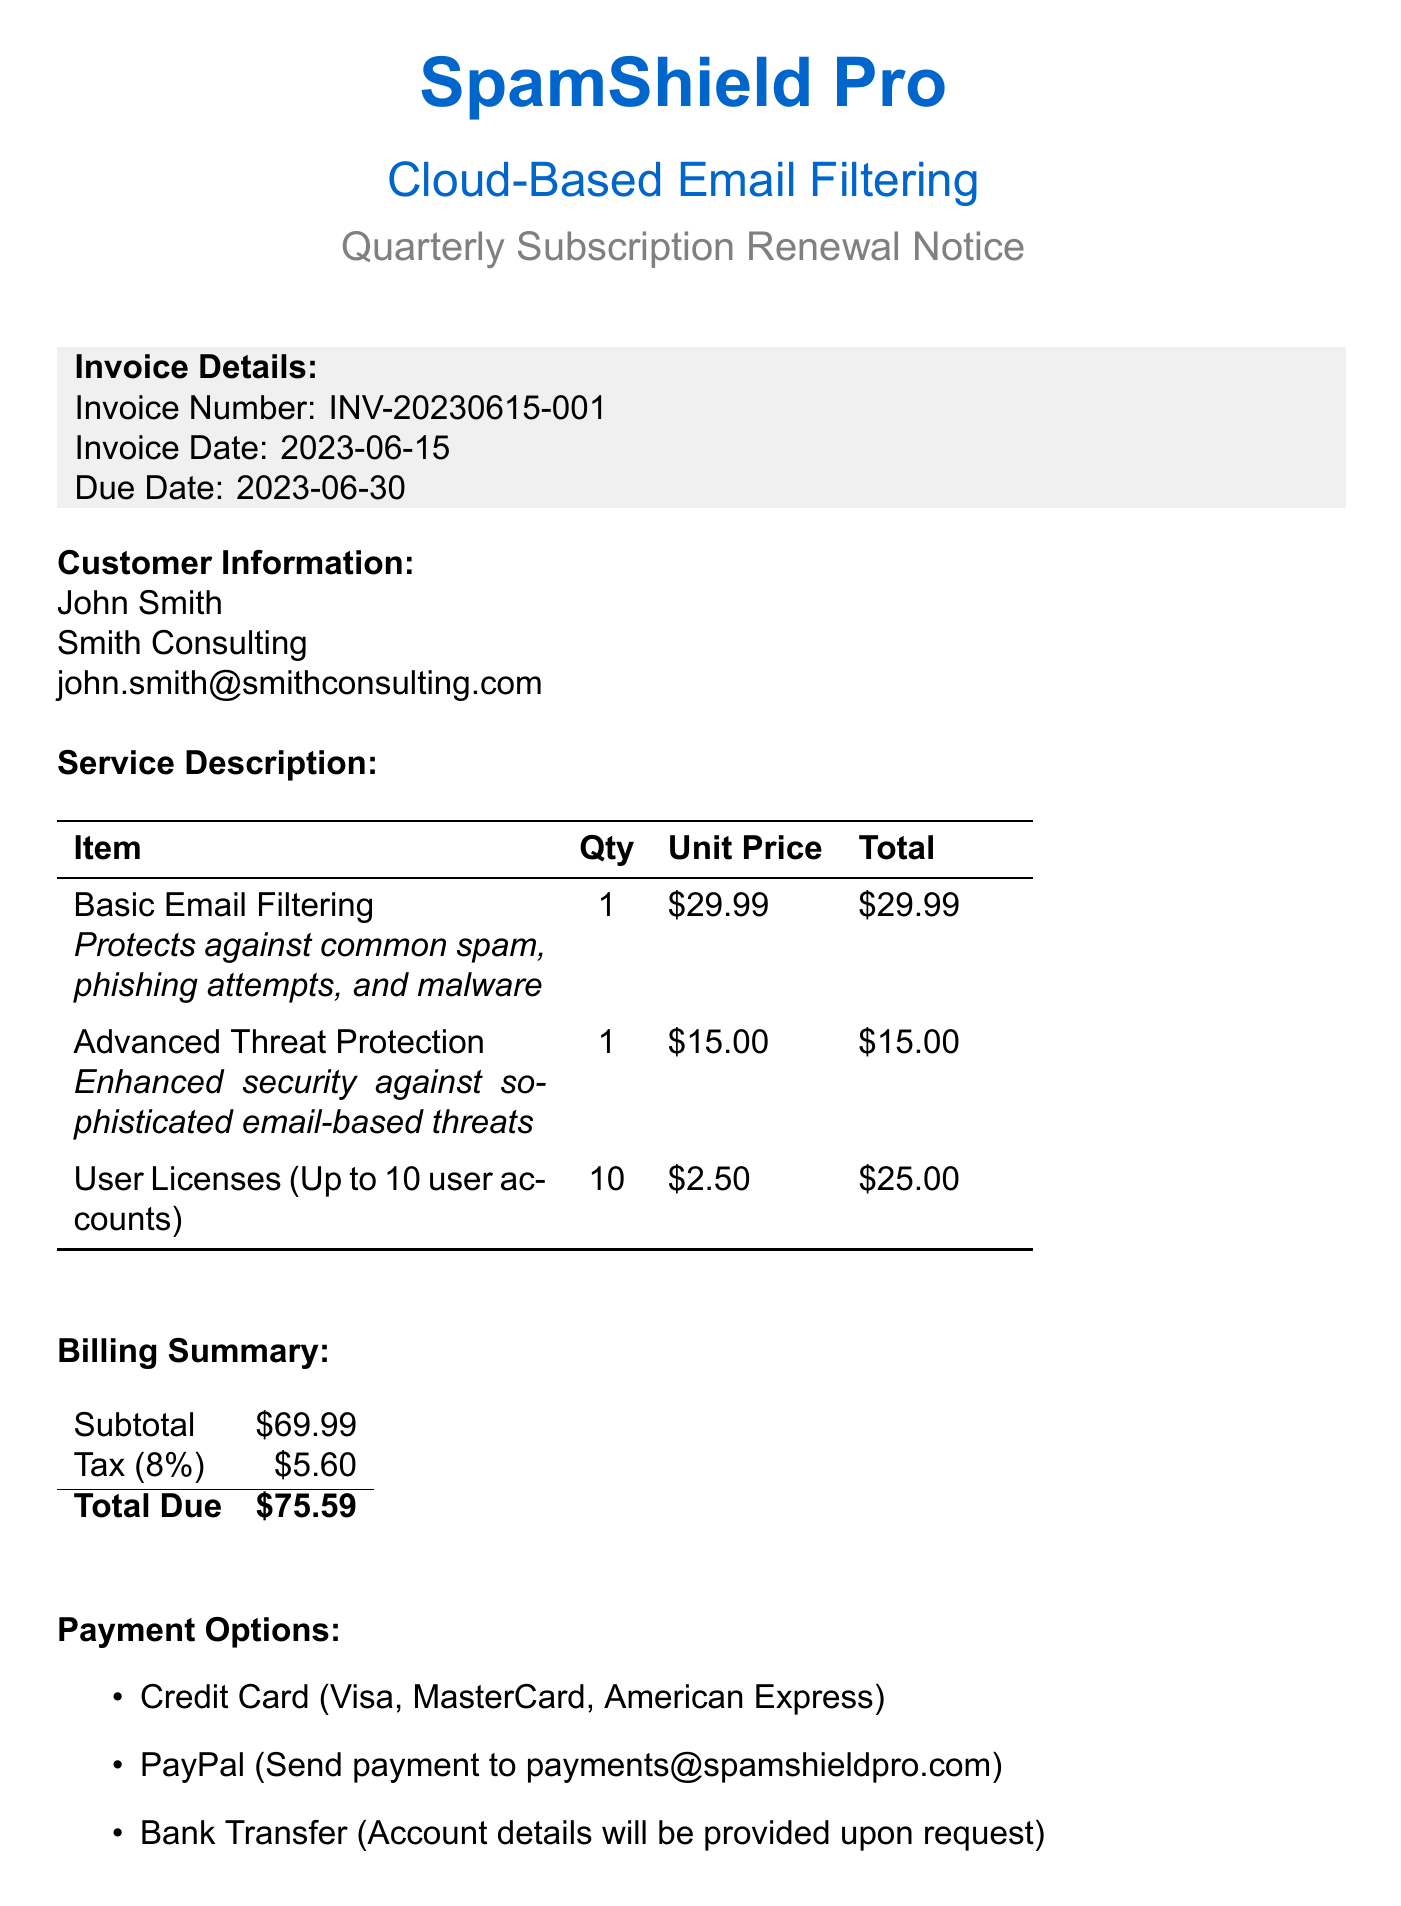What is the company name? The company name is mentioned at the top of the document as SpamShield Pro.
Answer: SpamShield Pro What is the invoice number? The invoice number is listed in the invoice details section as INV-20230615-001.
Answer: INV-20230615-001 What is the total due amount? The total due amount is calculated in the billing summary as $75.59.
Answer: $75.59 How many user licenses are included? The service description states there are up to 10 user accounts allowed.
Answer: 10 What is the tax rate? The tax rate mentioned in the billing summary is 0.08, which corresponds to an 8% tax.
Answer: 8% What is the payment method that allows email payment? PayPal is the payment method that specifies sending payment to an email address.
Answer: PayPal How soon must one cancel the subscription to avoid automatic renewal? The terms state you must cancel 7 days before the renewal date to avoid automatic renewal.
Answer: 7 days What type of support is available? The document mentions email support and live chat as available customer support options.
Answer: Email support and live chat What is one of the upcoming features? The document lists several upcoming features, including AI-powered content analysis as one of them.
Answer: AI-powered content analysis 